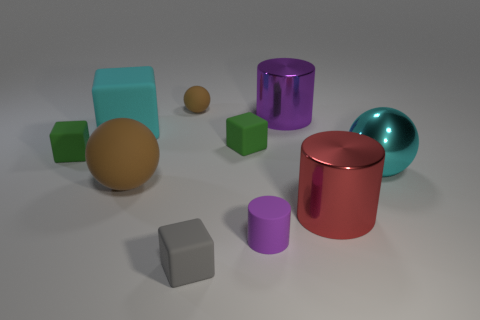There is a small matte thing that is the same shape as the purple metal object; what color is it?
Your response must be concise. Purple. Does the purple cylinder in front of the cyan block have the same material as the large cyan sphere?
Offer a very short reply. No. What number of small things are cyan shiny things or yellow metallic things?
Offer a terse response. 0. How big is the purple matte cylinder?
Provide a short and direct response. Small. Is the size of the purple matte cylinder the same as the matte block that is right of the small gray thing?
Offer a terse response. Yes. What number of cyan objects are either small cylinders or blocks?
Give a very brief answer. 1. What number of big gray things are there?
Your answer should be compact. 0. What size is the rubber sphere that is behind the cyan sphere?
Your response must be concise. Small. Does the cyan matte object have the same size as the red object?
Offer a terse response. Yes. What number of things are either large purple cylinders or matte cubes that are behind the red metallic cylinder?
Keep it short and to the point. 4. 